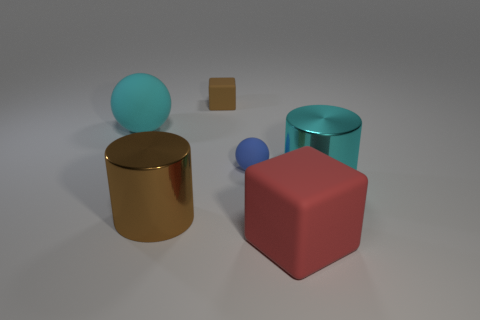What number of other tiny things are the same shape as the red object?
Provide a short and direct response. 1. Is the shape of the small brown rubber object the same as the large rubber thing right of the small brown cube?
Provide a short and direct response. Yes. There is a large thing that is the same color as the big matte sphere; what is its shape?
Provide a short and direct response. Cylinder. Are there any large cyan cylinders that have the same material as the big brown thing?
Make the answer very short. Yes. What is the material of the block that is in front of the large rubber object that is behind the big brown metallic cylinder?
Keep it short and to the point. Rubber. There is a sphere to the left of the brown object that is behind the big metal object to the left of the brown matte cube; what is its size?
Provide a short and direct response. Large. What number of other objects are there of the same shape as the cyan rubber object?
Offer a very short reply. 1. Does the large cylinder left of the blue matte sphere have the same color as the matte block that is behind the brown shiny object?
Your answer should be compact. Yes. What color is the matte cube that is the same size as the brown metal cylinder?
Your answer should be compact. Red. Is there a big cylinder that has the same color as the small rubber block?
Keep it short and to the point. Yes. 